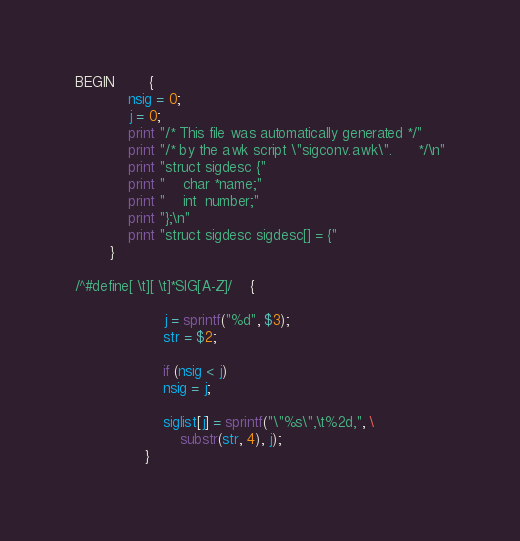<code> <loc_0><loc_0><loc_500><loc_500><_Awk_>BEGIN		{
		    nsig = 0;
		    j = 0;
		    print "/* This file was automatically generated */"
		    print "/* by the awk script \"sigconv.awk\".      */\n"
		    print "struct sigdesc {"
		    print "    char *name;"
		    print "    int  number;"
		    print "};\n"
		    print "struct sigdesc sigdesc[] = {"
		}

/^#define[ \t][ \t]*SIG[A-Z]/	{

				    j = sprintf("%d", $3);
				    str = $2;

				    if (nsig < j) 
					nsig = j;

				    siglist[j] = sprintf("\"%s\",\t%2d,", \
						substr(str, 4), j);
				}</code> 